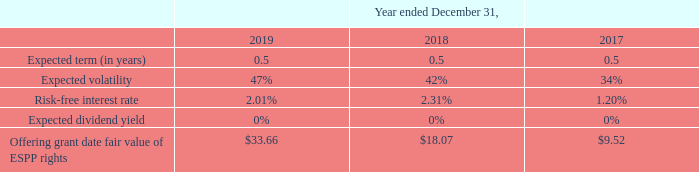The ESPP provides for annual increases in the number of shares available for issuance under the ESPP on the first day of each fiscal year beginning in fiscal 2014, equal to the least of: (i) 1% of the outstanding shares of all classes of common stock on the last day of the immediately preceding year; (ii) 1,250,000 shares; or (iii) such other amount as may be determined by the board of directors. During the year ended December 31, 2019, a total of 810,459 shares of Class A common stock were added to the ESPP Plan in connection with the annual increase provision. At December 31, 2019, a total of 3,918,712 shares were available for issuance under the ESPP.
The weighted-average assumptions used to value ESPP rights under the Black-Scholes-Merton option-pricing model and the resulting offering grant date fair value of ESPP rights granted in the periods presented were as follows:
As of December 31, 2019 and 2018, there was approximately $2.3 million and $1.5 million of unrecognized share-based compensation expense, net of estimated forfeitures, related to ESPP, which will be recognized on a straight-line basis over the remaining weighted-average vesting periods of approximately 0.4 years, respectively
As of December 31, 2019 and 2018, what are the respective number of unrecognized share-based compensation expense, net of estimated forfeitures, related to ESPP? $2.3 million, $1.5 million. What are the respective expected volatility of ESPP rights for the year ended December 31, 2019 and 2018? 47%, 42%. What are the respective expected volatility of ESPP rights for the year ended December 31, 2018 and 2017? 42%, 34%. What is the percentage change in the offering grant date fair value of ESPP rights between 2017 and 2018?
Answer scale should be: percent. (18.07 - 9.52)/9.52 
Answer: 89.81. What is the percentage change in the offering grant date fair value of ESPP rights between 2018 and 2019?
Answer scale should be: percent. (33.66 - 18.07)/18.07 
Answer: 86.28. What is the average offering grant date fair value of ESPP rights between 2017 to 2019? (33.66 + 18.07 + 9.52)/3 
Answer: 20.42. 